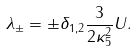Convert formula to latex. <formula><loc_0><loc_0><loc_500><loc_500>\lambda _ { \pm } = \pm \delta _ { 1 , 2 } \frac { 3 } { 2 \kappa _ { 5 } ^ { 2 } } U .</formula> 